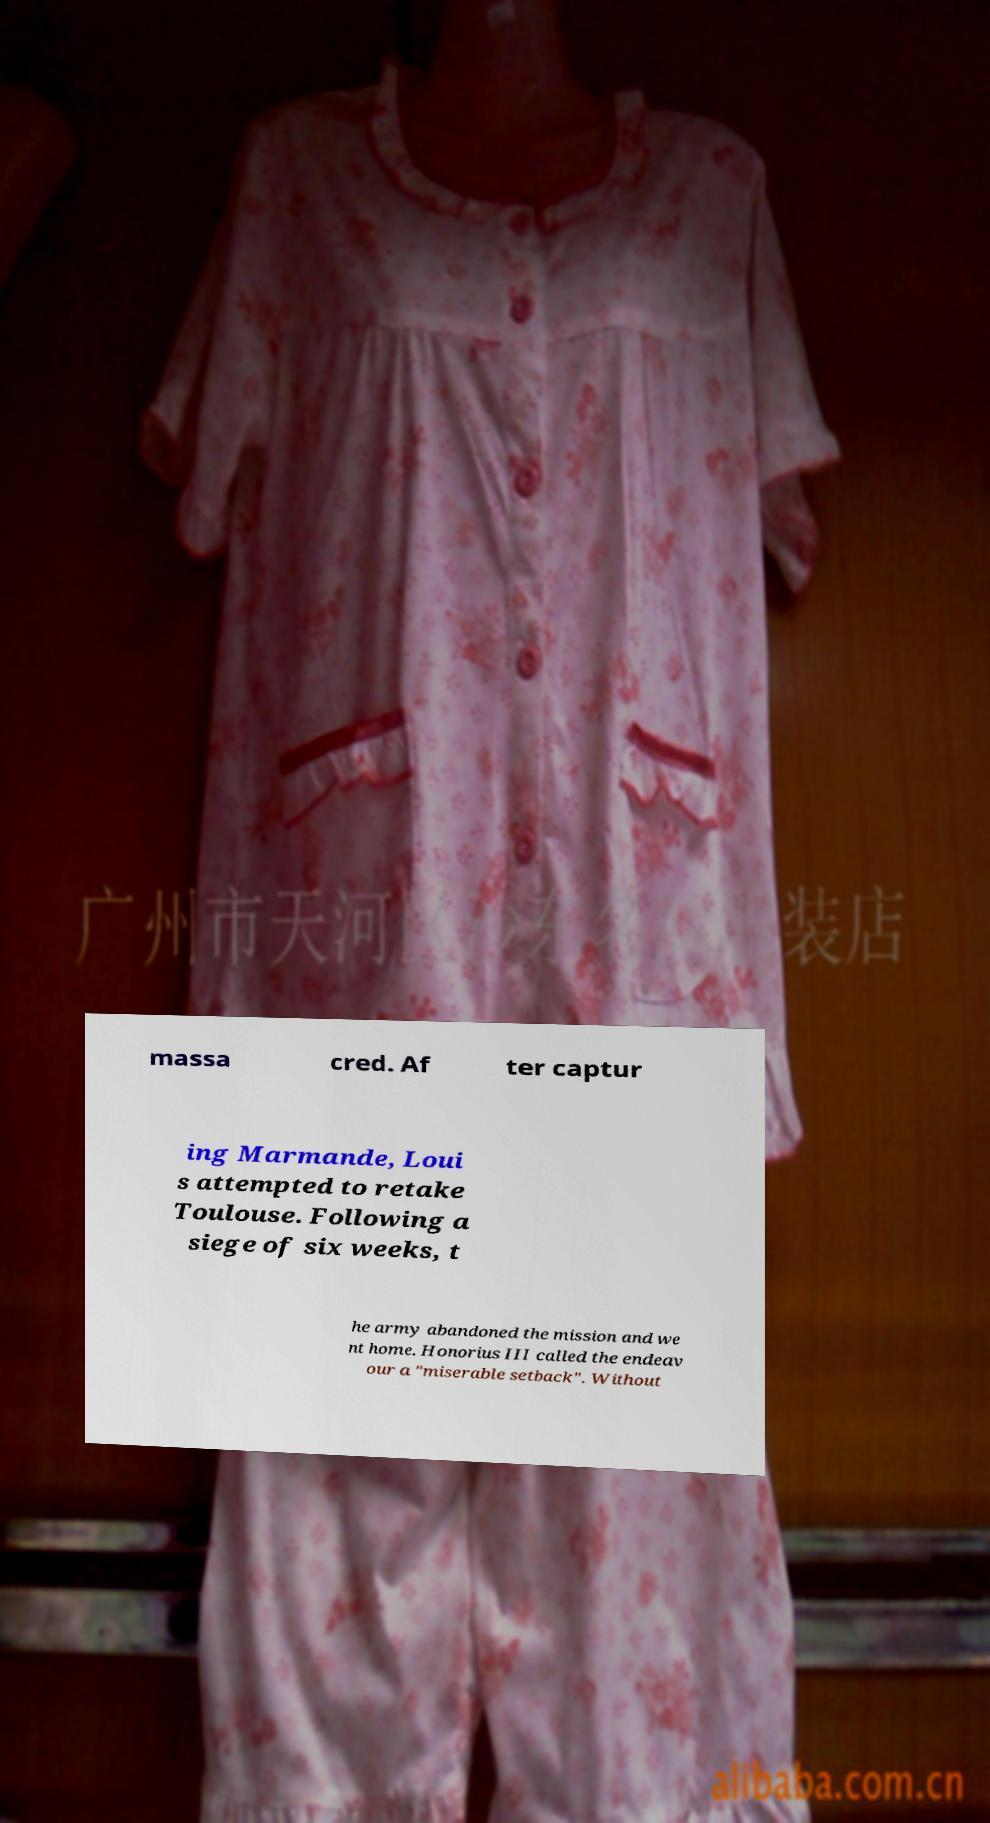Please read and relay the text visible in this image. What does it say? massa cred. Af ter captur ing Marmande, Loui s attempted to retake Toulouse. Following a siege of six weeks, t he army abandoned the mission and we nt home. Honorius III called the endeav our a "miserable setback". Without 